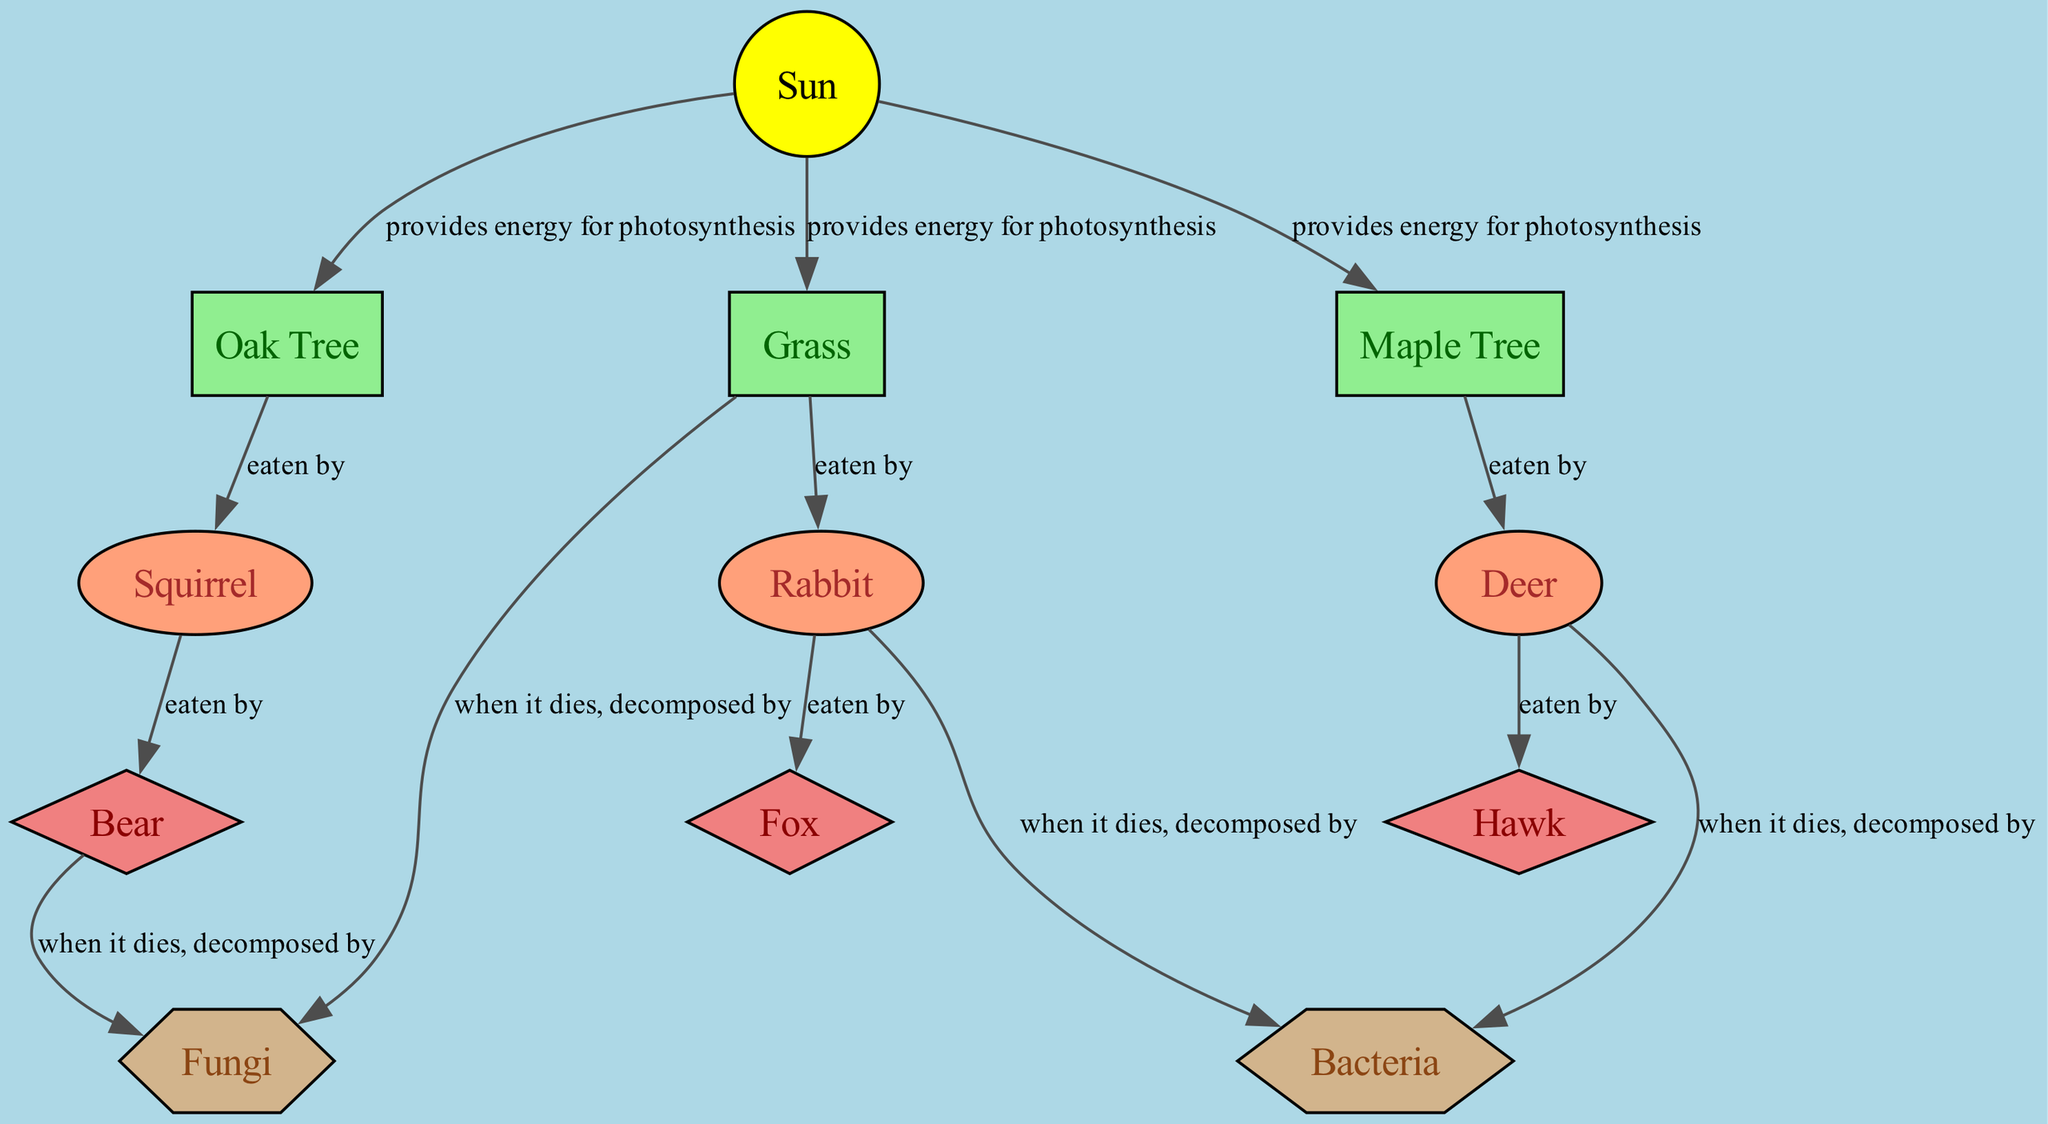What is the primary energy source for the forest ecosystem? The diagram shows the "Sun" as the primary energy source for the forest ecosystem, indicated by its position at the top and its role in providing energy for photosynthesis to producers.
Answer: Sun How many types of primary consumers are present? There are three primary consumers listed in the diagram: Rabbit, Deer, and Squirrel. This is counted from the nodes categorized as primary consumers.
Answer: 3 Which producer is eaten by Squirrel? The diagram indicates that the Squirrel is eaten by the Oak Tree since there is a direct edge labeled "eaten by" from the Oak Tree to Squirrel.
Answer: Oak Tree Which organism is a secondary consumer that eats Deer? The diagram shows that the Hawk is a secondary consumer that eats the Deer, as indicated by the connecting edge labeled "eaten by" between Deer and Hawk.
Answer: Hawk What happens to Bear when it dies? The diagram specifies that when the Bear dies, it is decomposed by Fungi, indicated by the direct edge labeled "when it dies, decomposed by" leading from Bear to Fungi.
Answer: Fungi Identify one decomposition role entity for Rabbit. According to the diagram, after the Rabbit dies, it is decomposed by Bacteria, as represented by the edge labeled "when it dies, decomposed by" connecting Rabbit and Bacteria.
Answer: Bacteria How many producers are in the ecosystem? The diagram displays three producers: Oak Tree, Maple Tree, and Grass, which can be counted directly from the nodes classified as producers.
Answer: 3 Which type of organism does Grass serve as food for? The diagram indicates that Grass serves as food for the Rabbit, shown by the edge labeled "eaten by" that connects Grass to Rabbit.
Answer: Rabbit What is the relationship between the Sun and Grass? The Sun provides energy for photosynthesis to Grass, as indicated by the edge labeled "provides energy for photosynthesis" connecting the Sun to Grass.
Answer: provides energy for photosynthesis 